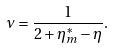<formula> <loc_0><loc_0><loc_500><loc_500>\nu = \frac { 1 } { 2 + \eta _ { m } ^ { * } - \eta } .</formula> 